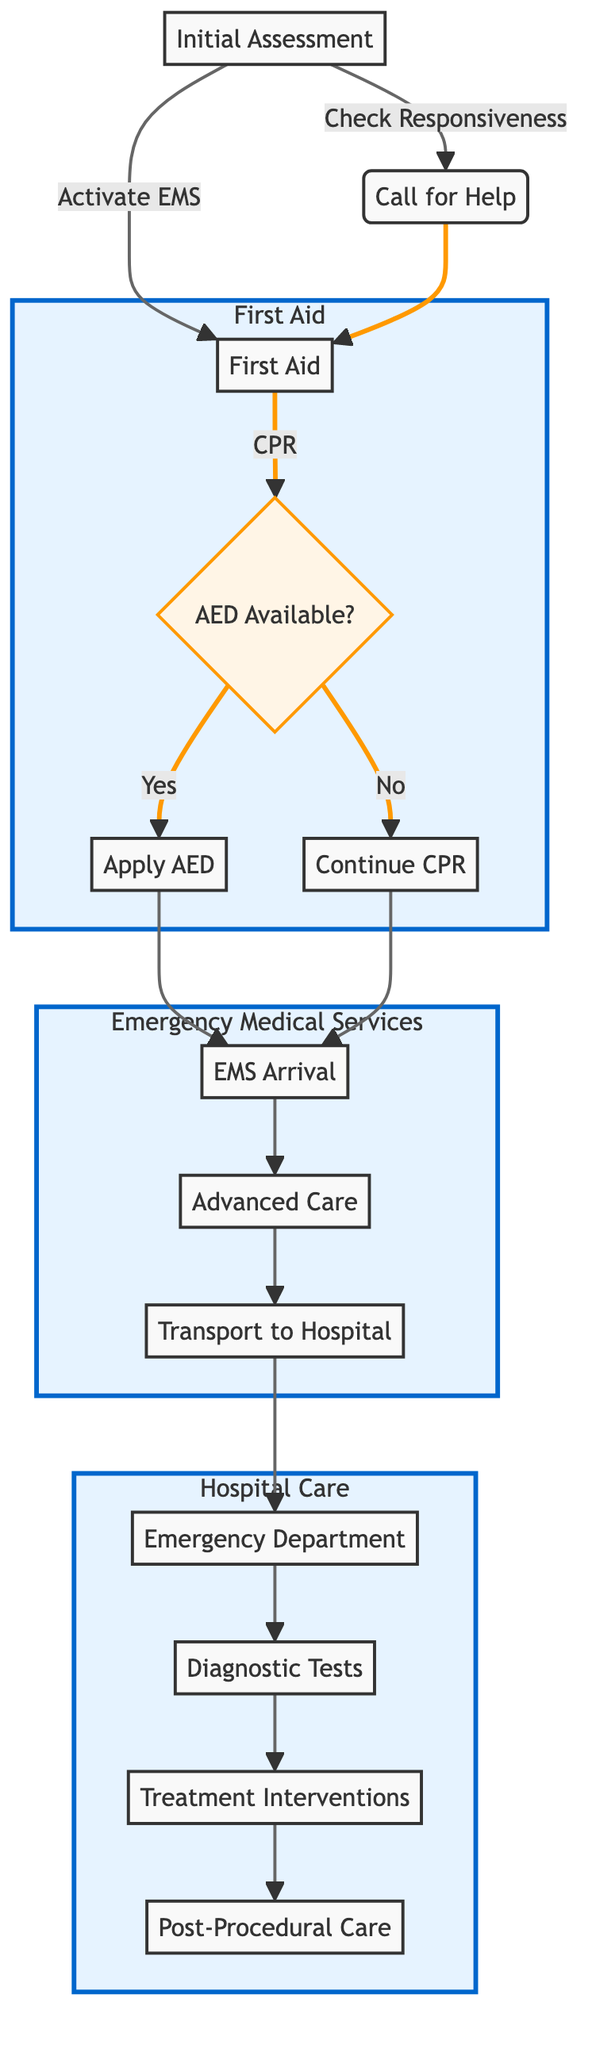What is the first step in the pathway? The first step in the pathway is the "Initial Assessment," where the responder checks responsiveness and calls for help.
Answer: Initial Assessment How many main sections are in the diagram? The diagram contains three main sections: First Aid, Emergency Medical Services, and Hospital Care.
Answer: Three What should be done if an AED is available? If an AED is available, the next step is to apply the AED pads on the patient's chest and follow the device prompts.
Answer: Apply AED What action is taken after CPR if an AED is not available? If an AED is not available, the responder should continue performing CPR.
Answer: Continue CPR What comes after EMS arrival in the pathway? After EMS arrival, the next step is providing Advanced Care.
Answer: Advanced Care What type of tests are conducted in the Hospital Care section? The tests conducted in the Hospital Care section include an Electrocardiogram and Blood Tests to assess the patient's condition.
Answer: Electrocardiogram and Blood Tests What is involved in the Treatment Interventions? The Treatment Interventions involve administering medications and transferring the patient to the Cath Lab if needed.
Answer: Medications and Cath Lab What is the purpose of monitoring in Post-Procedural Care? The purpose of monitoring in Post-Procedural Care is continuous monitoring in the ICU and planning for rehabilitation before discharge.
Answer: Continuous monitoring in ICU What initiates the Emergency Medical Services section? The EMS section is initiated by the EMS arrival on the scene following the first aid response.
Answer: EMS Arrival 